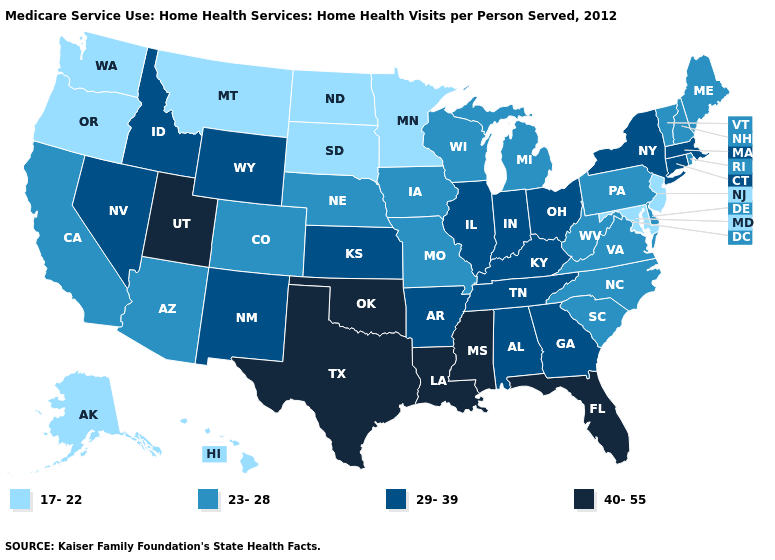Name the states that have a value in the range 23-28?
Give a very brief answer. Arizona, California, Colorado, Delaware, Iowa, Maine, Michigan, Missouri, Nebraska, New Hampshire, North Carolina, Pennsylvania, Rhode Island, South Carolina, Vermont, Virginia, West Virginia, Wisconsin. Does Vermont have a lower value than Iowa?
Keep it brief. No. What is the lowest value in the Northeast?
Write a very short answer. 17-22. What is the lowest value in the USA?
Be succinct. 17-22. Does Arizona have the highest value in the USA?
Keep it brief. No. Does New Mexico have a lower value than Mississippi?
Concise answer only. Yes. Does New Mexico have the highest value in the USA?
Answer briefly. No. What is the lowest value in the West?
Keep it brief. 17-22. What is the highest value in the USA?
Concise answer only. 40-55. Among the states that border New York , does New Jersey have the lowest value?
Keep it brief. Yes. What is the value of Alabama?
Quick response, please. 29-39. Does Kansas have the highest value in the USA?
Quick response, please. No. Which states have the highest value in the USA?
Short answer required. Florida, Louisiana, Mississippi, Oklahoma, Texas, Utah. Name the states that have a value in the range 40-55?
Give a very brief answer. Florida, Louisiana, Mississippi, Oklahoma, Texas, Utah. 